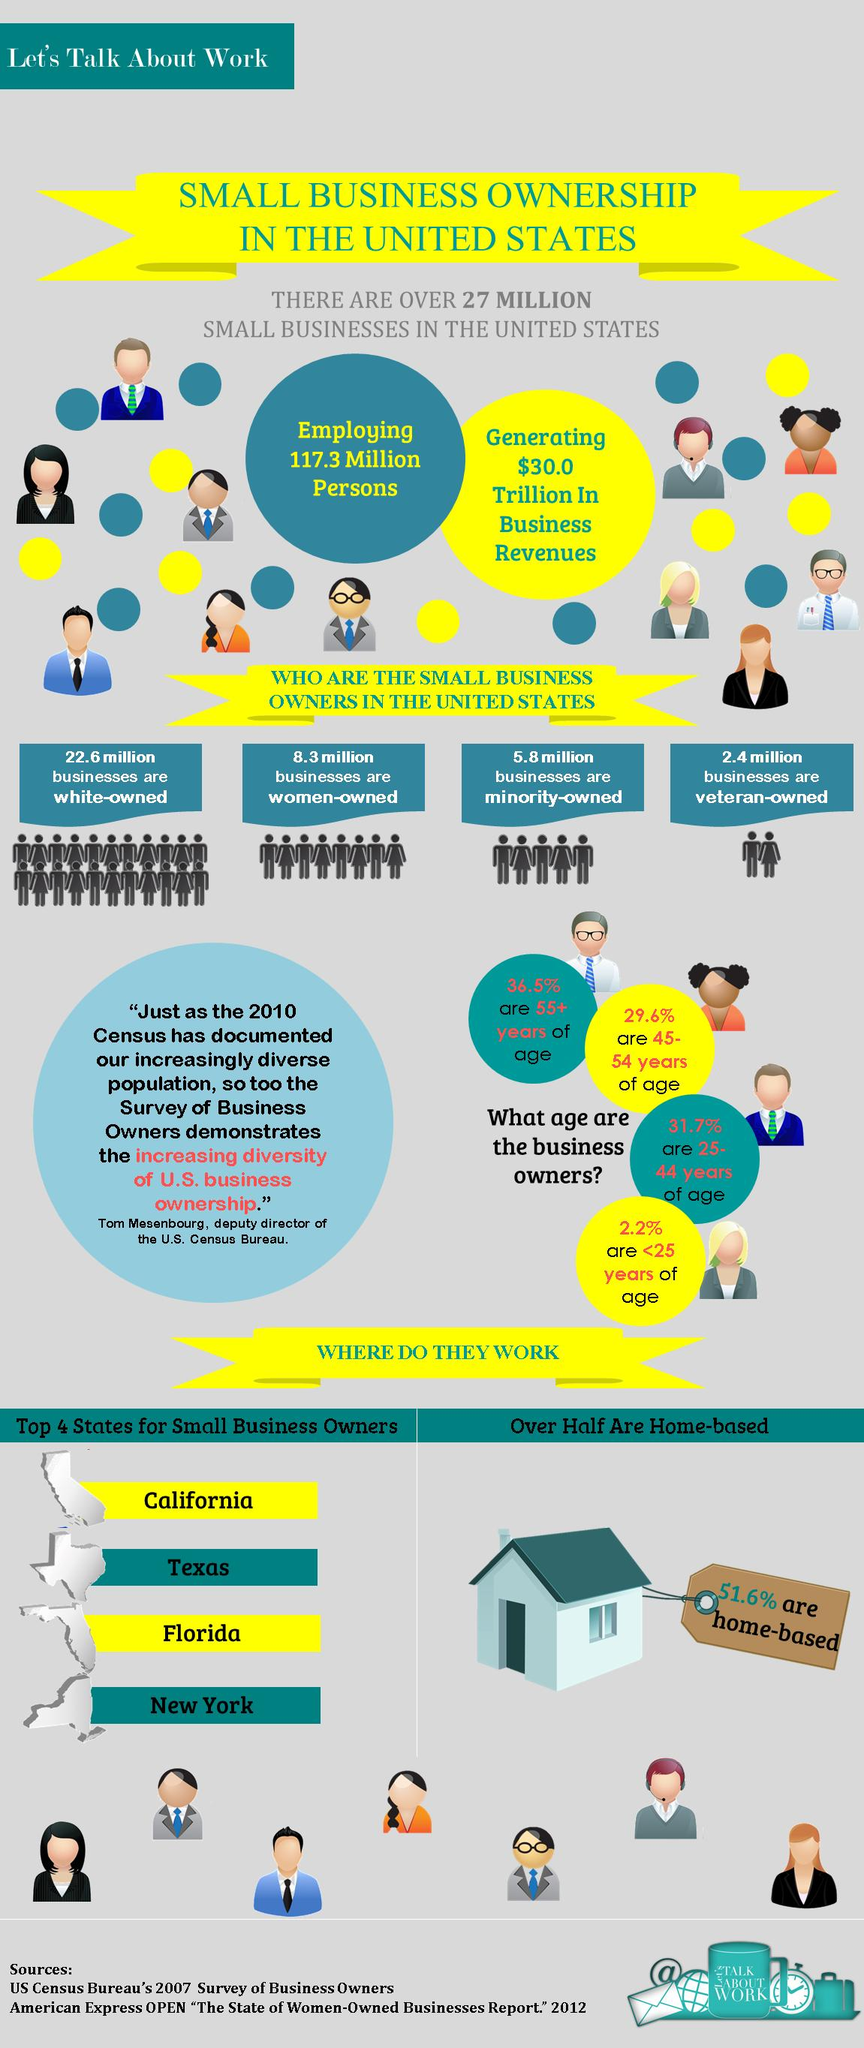Identify some key points in this picture. Seventy-percent-four percent of individuals are not between the ages of 45 and 54. Approximately 63.5% of the population is not 55 years of age. A large percentage of individuals aged 25-44 years old are not included in the given percentage. According to the data, only 48.4% of businesses are not home-based. Ninety-seven point eight percent of the population is over 25 years of age. 